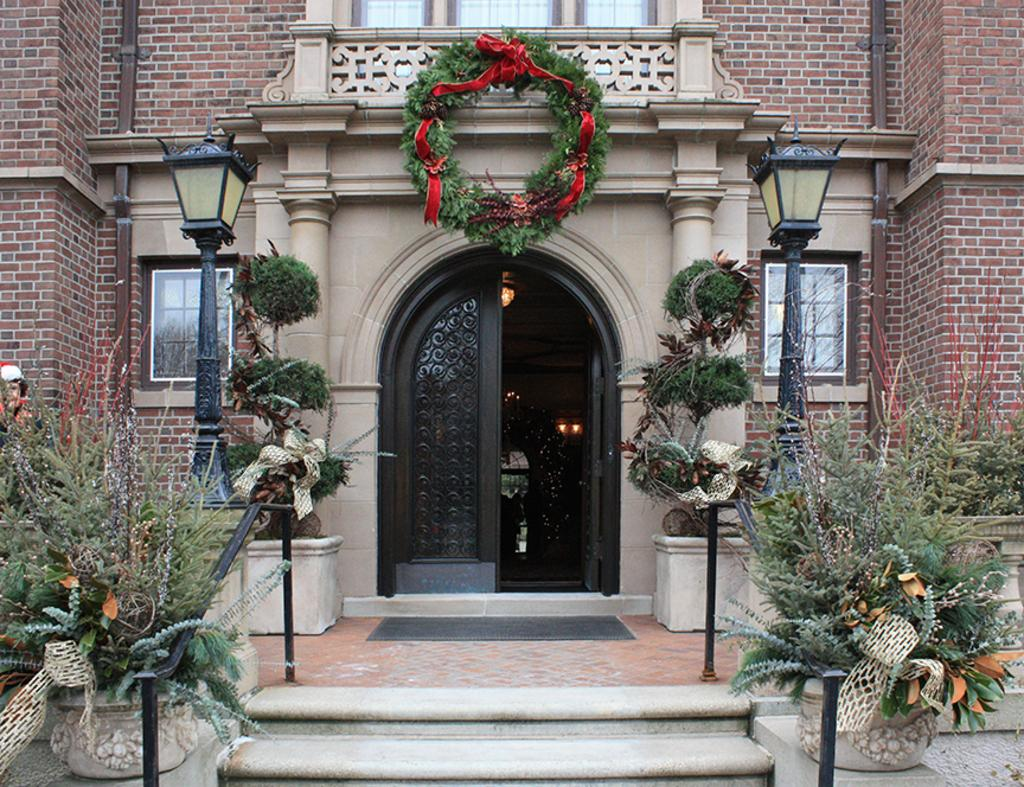What type of plants can be seen in the image? There are house plants in the image. What objects are present that resemble long, thin bars? There are rods in the image. What architectural feature is visible in the image? There are steps in the image. What type of lighting is present in the image? There is light on poles in the image. What decorative item can be seen in the image? There is a garland in the image. What type of structure is visible in the image? There is a building in the image. What entrance is present in the image? There is a door in the image. What type of illumination is present in the image? There are lights in the image. Where is the person located in the image? There is a person on the left side of the image. What type of wire is being exchanged between the person and the house plants in the image? There is no wire being exchanged between the person and the house plants in the image. What type of dinner is being served in the image? There is no dinner being served in the image. 